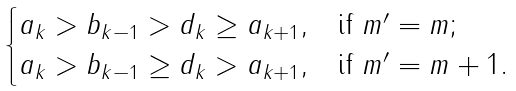<formula> <loc_0><loc_0><loc_500><loc_500>\begin{cases} a _ { k } > b _ { k - 1 } > d _ { k } \geq a _ { k + 1 } , & \text {if $m^{\prime}=m$} ; \\ a _ { k } > b _ { k - 1 } \geq d _ { k } > a _ { k + 1 } , & \text {if $m^{\prime}=m+1$} . \end{cases}</formula> 